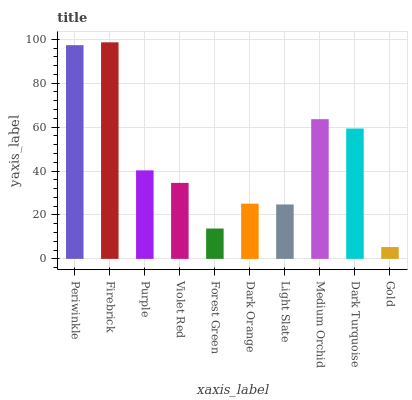Is Gold the minimum?
Answer yes or no. Yes. Is Firebrick the maximum?
Answer yes or no. Yes. Is Purple the minimum?
Answer yes or no. No. Is Purple the maximum?
Answer yes or no. No. Is Firebrick greater than Purple?
Answer yes or no. Yes. Is Purple less than Firebrick?
Answer yes or no. Yes. Is Purple greater than Firebrick?
Answer yes or no. No. Is Firebrick less than Purple?
Answer yes or no. No. Is Purple the high median?
Answer yes or no. Yes. Is Violet Red the low median?
Answer yes or no. Yes. Is Medium Orchid the high median?
Answer yes or no. No. Is Medium Orchid the low median?
Answer yes or no. No. 